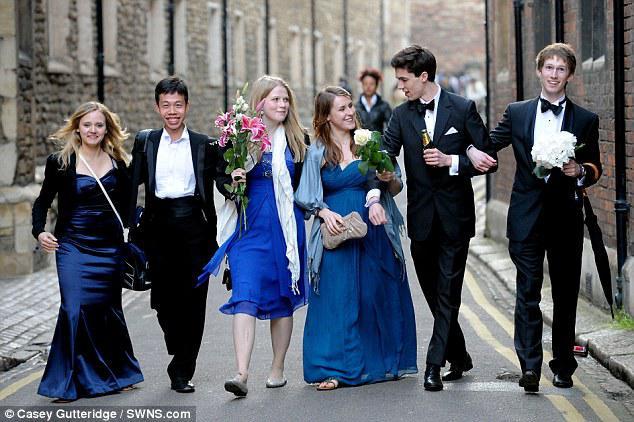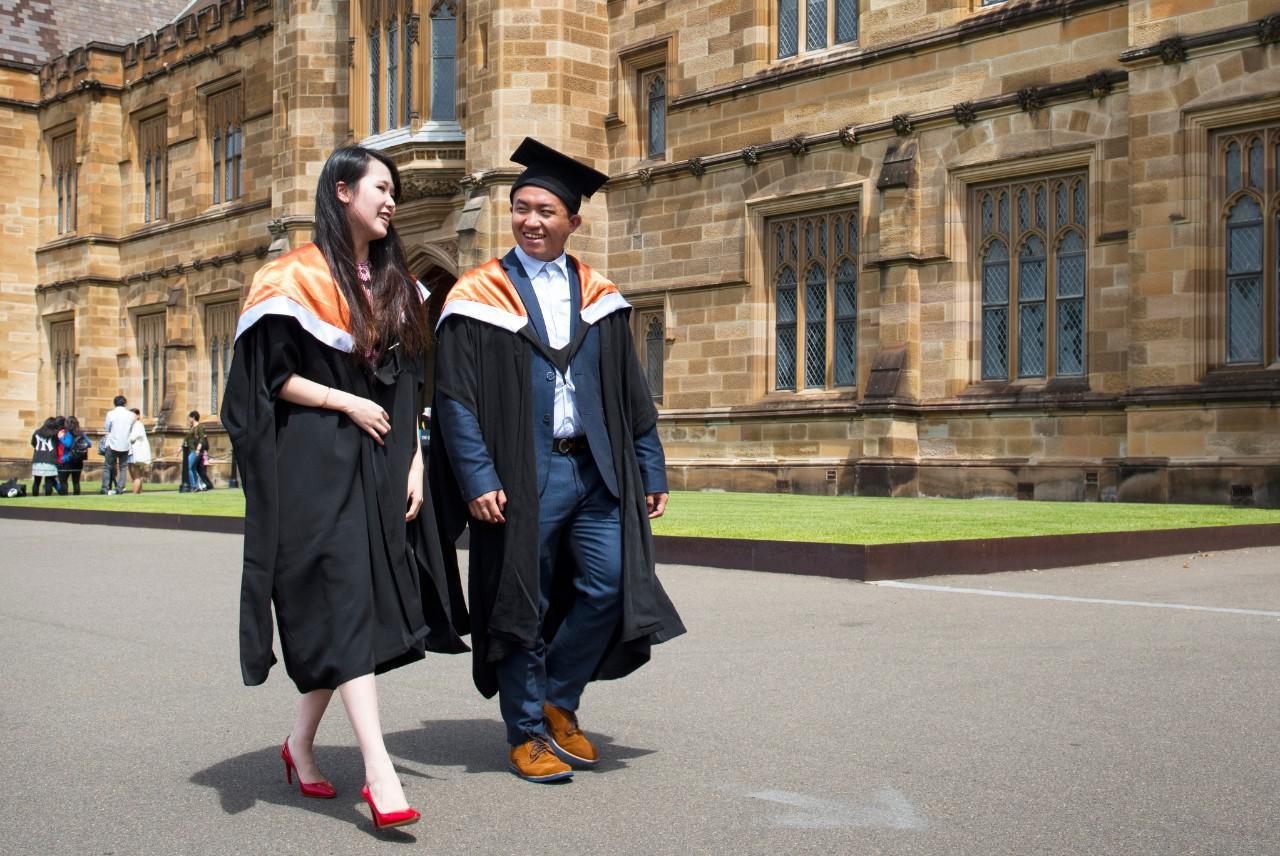The first image is the image on the left, the second image is the image on the right. For the images shown, is this caption "There is exactly three graduation students in the right image." true? Answer yes or no. No. The first image is the image on the left, the second image is the image on the right. Analyze the images presented: Is the assertion "An image shows exactly one male and one female graduate, wearing matching robes." valid? Answer yes or no. Yes. 